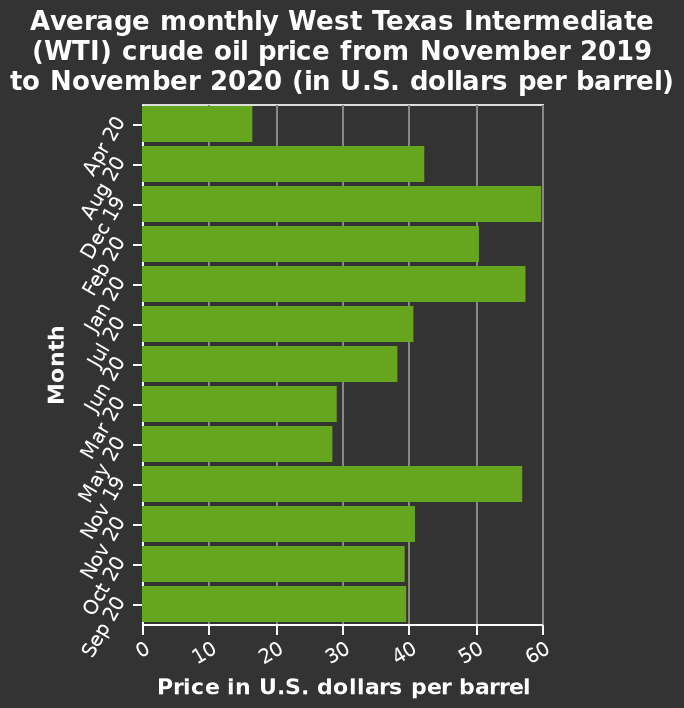<image>
When were the prices per barrel for crude oil in the West Texas highest?  The prices per barrel for crude oil in the West Texas were highest in August 2019. Where did the highest prices per barrel of crude oil occur? The highest prices per barrel of crude oil occurred in the West Texas. How much was the difference in price per barrel between August 2019 and April 2020? The description does not provide the specific difference in price per barrel between August 2019 and April 2020. 